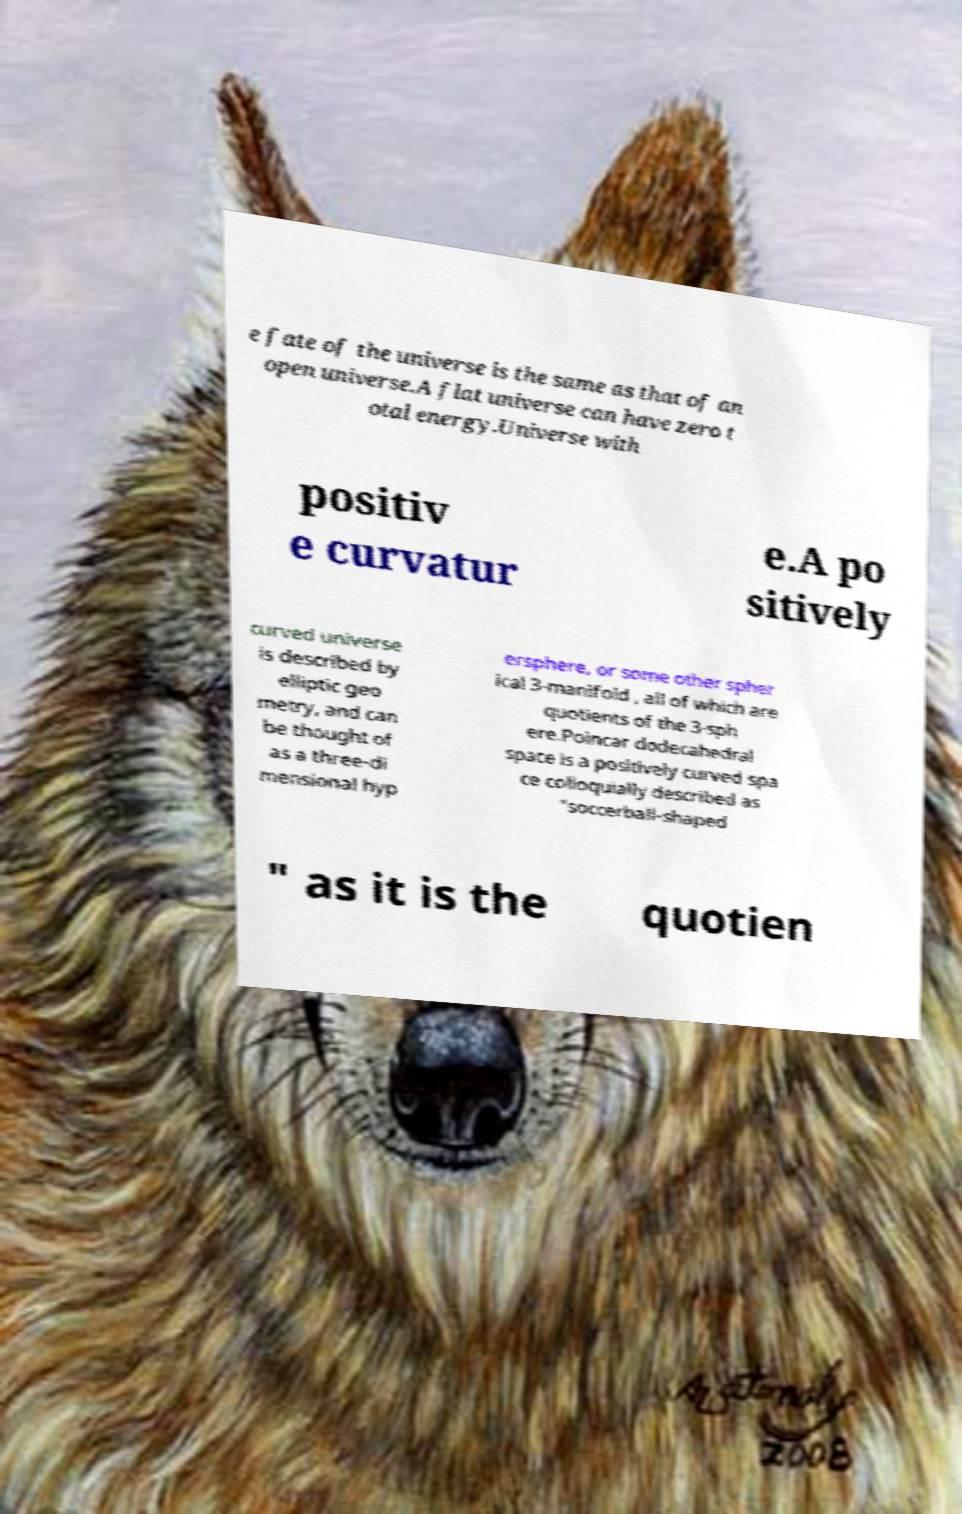Can you accurately transcribe the text from the provided image for me? e fate of the universe is the same as that of an open universe.A flat universe can have zero t otal energy.Universe with positiv e curvatur e.A po sitively curved universe is described by elliptic geo metry, and can be thought of as a three-di mensional hyp ersphere, or some other spher ical 3-manifold , all of which are quotients of the 3-sph ere.Poincar dodecahedral space is a positively curved spa ce colloquially described as "soccerball-shaped " as it is the quotien 